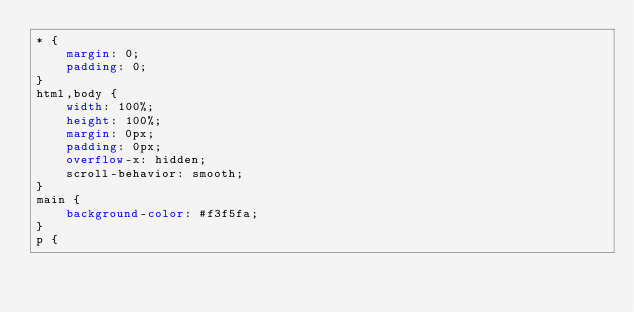Convert code to text. <code><loc_0><loc_0><loc_500><loc_500><_CSS_>* {
    margin: 0;
    padding: 0;
}
html,body {
    width: 100%;
    height: 100%;
    margin: 0px;
    padding: 0px;
    overflow-x: hidden;
    scroll-behavior: smooth;
}
main {
    background-color: #f3f5fa;
}
p {</code> 